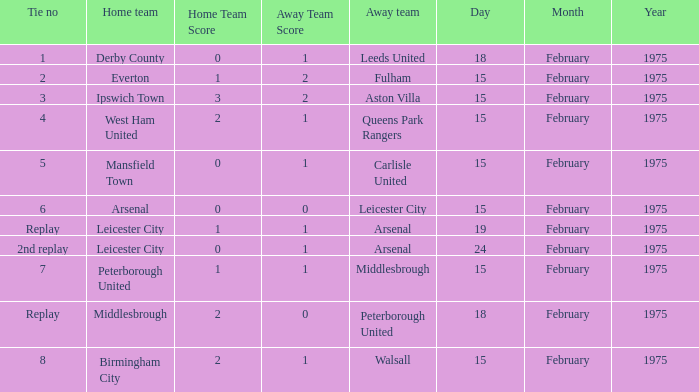What was the date when the away team was carlisle united? 15 February 1975. 